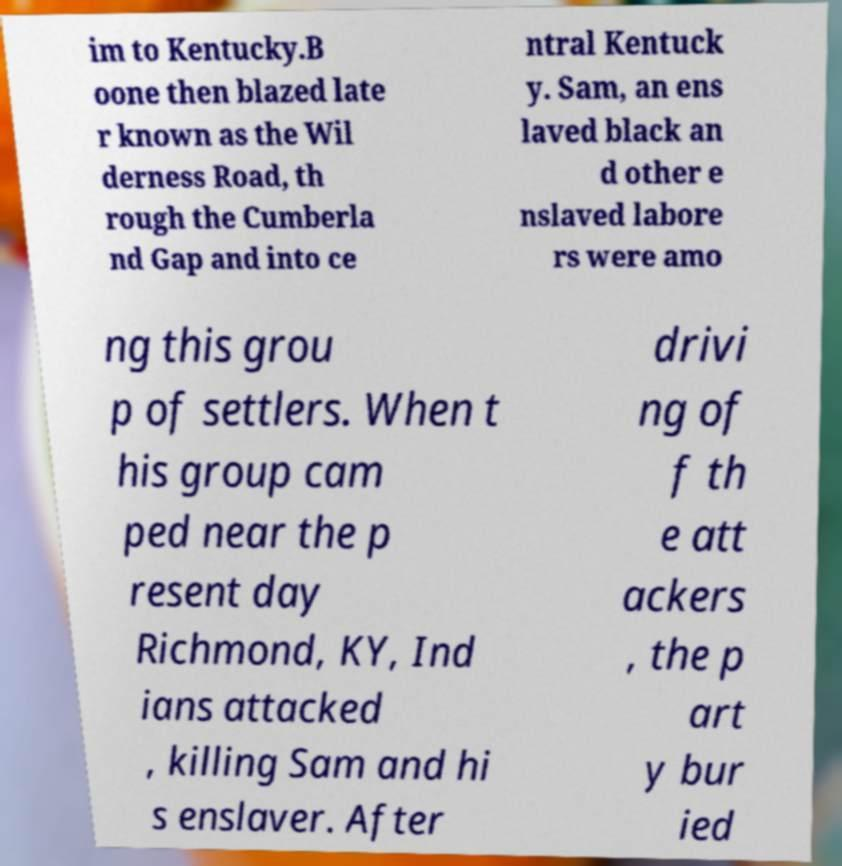For documentation purposes, I need the text within this image transcribed. Could you provide that? im to Kentucky.B oone then blazed late r known as the Wil derness Road, th rough the Cumberla nd Gap and into ce ntral Kentuck y. Sam, an ens laved black an d other e nslaved labore rs were amo ng this grou p of settlers. When t his group cam ped near the p resent day Richmond, KY, Ind ians attacked , killing Sam and hi s enslaver. After drivi ng of f th e att ackers , the p art y bur ied 